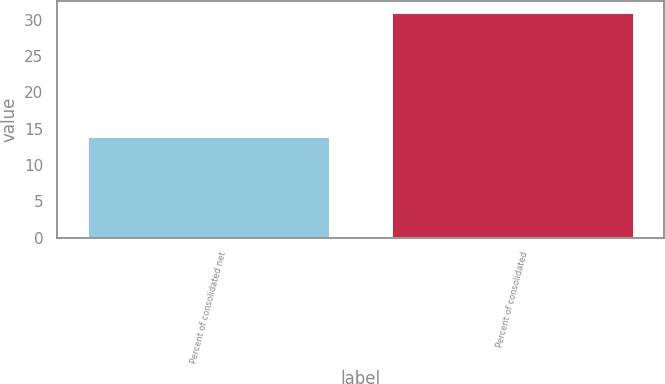<chart> <loc_0><loc_0><loc_500><loc_500><bar_chart><fcel>Percent of consolidated net<fcel>Percent of consolidated<nl><fcel>14<fcel>31<nl></chart> 